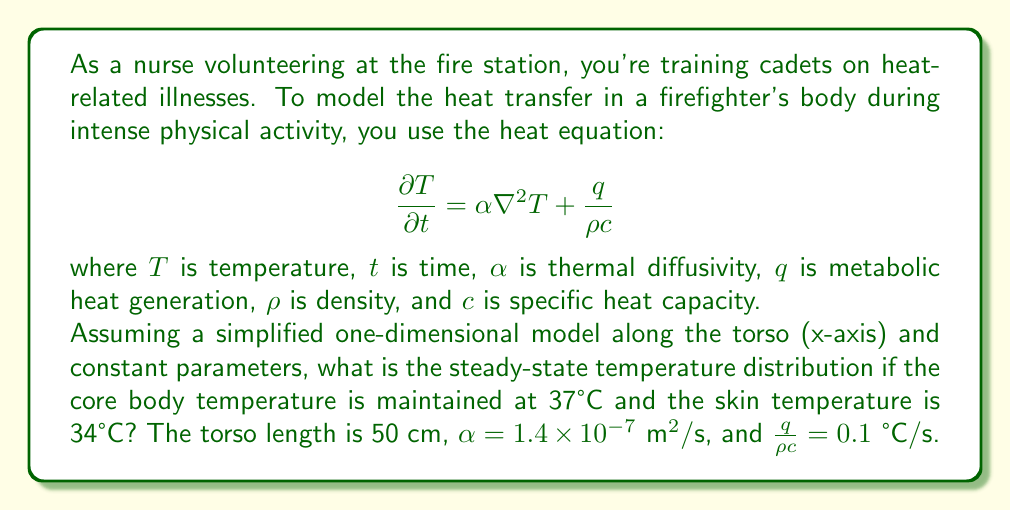What is the answer to this math problem? Let's approach this step-by-step:

1) For the steady-state condition, $\frac{\partial T}{\partial t} = 0$. The heat equation reduces to:

   $$0 = \alpha \frac{d^2T}{dx^2} + \frac{q}{\rho c}$$

2) Rearranging:

   $$\frac{d^2T}{dx^2} = -\frac{q}{\alpha \rho c} = -\frac{0.1}{1.4 \times 10^{-7}} = -714285.7 \text{ °C/m}^2$$

3) Integrate twice:

   $$\frac{dT}{dx} = -714285.7x + C_1$$
   $$T = -357142.85x^2 + C_1x + C_2$$

4) Apply boundary conditions:
   At $x = 0$, $T = 37 \text{ °C}$
   At $x = 0.5 \text{ m}$, $T = 34 \text{ °C}$

5) Solve for constants:
   $37 = C_2$
   $34 = -357142.85(0.5)^2 + 0.5C_1 + 37$
   $C_1 = 223214.3$

6) The final temperature distribution:

   $$T(x) = -357142.85x^2 + 223214.3x + 37$$

This quadratic function represents the steady-state temperature distribution along the torso.
Answer: $T(x) = -357142.85x^2 + 223214.3x + 37$ °C 